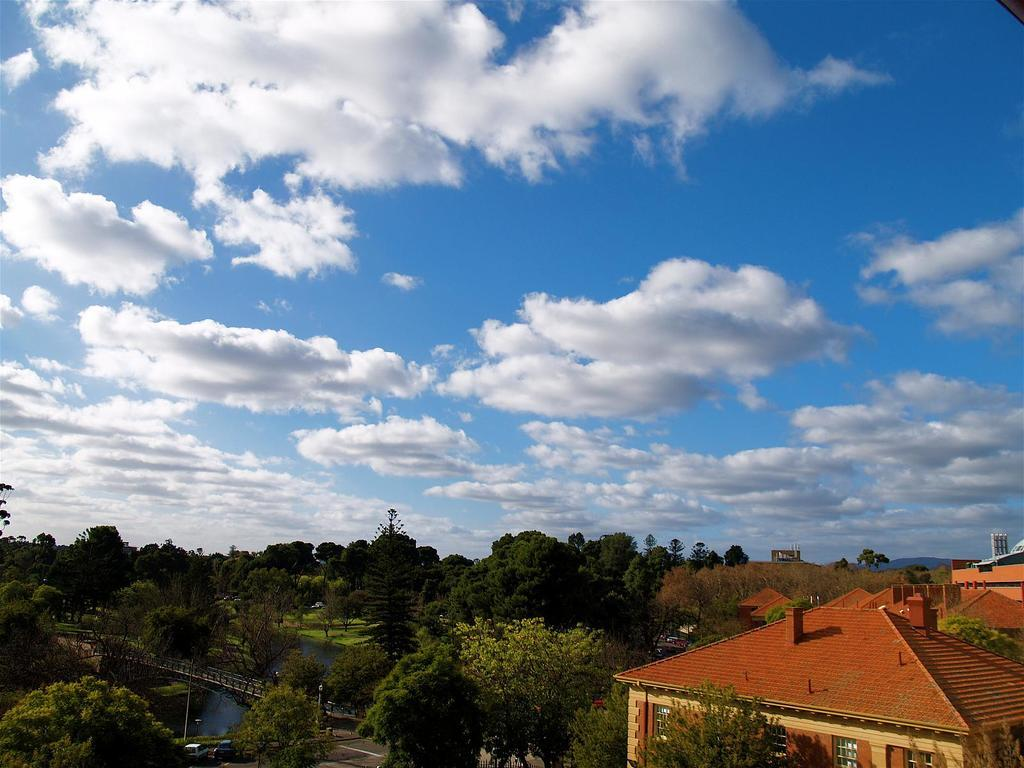What type of structures can be seen in the image? There are houses in the image. What else can be seen besides houses? There are poles and trees in the image. Is there any water visible in the image? Yes, there is a bridge over the water in the image. What can be seen in the background of the image? Clouds are visible in the background of the image. What title does the window have in the image? There is no window present in the image. How does the mind of the tree affect its growth in the image? There is no indication of the tree's mind or its growth in the image. 